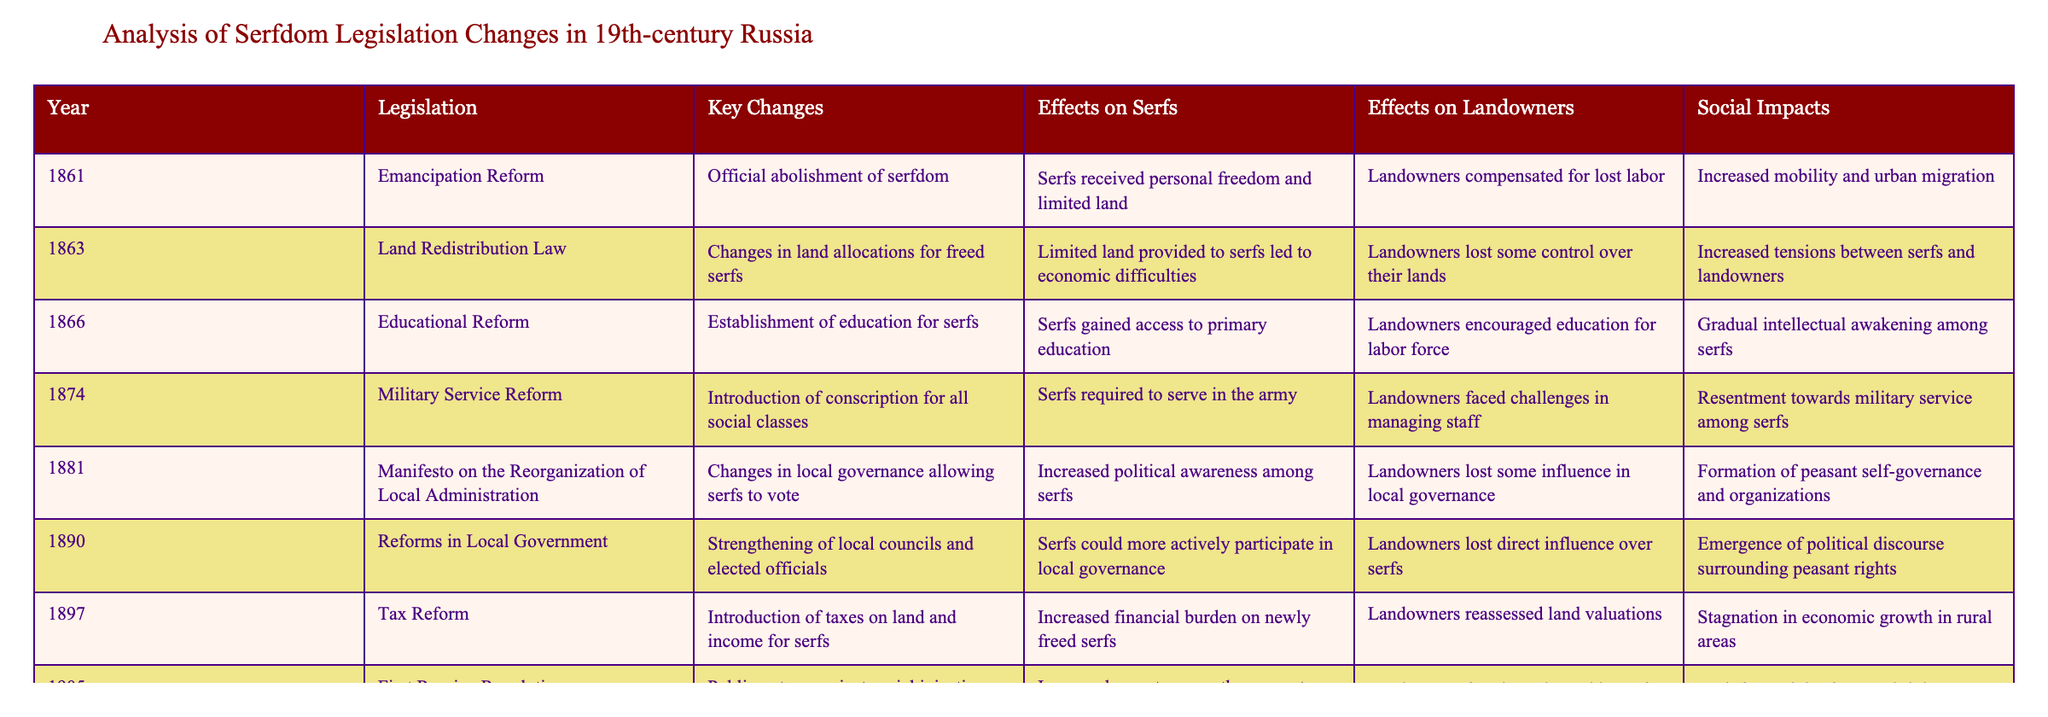What year did the Emancipation Reform take place? The table lists the years corresponding to the legislation changes, and the Emancipation Reform is noted in the first row as occurring in 1861.
Answer: 1861 What effects did the Land Redistribution Law have on serfs? According to the table, the effects of the Land Redistribution Law on serfs included limited land provided, which led to economic difficulties.
Answer: Economic difficulties How many significant reforms related to serfdom were introduced between 1861 and 1905? By counting the rows in the table between the years 1861 and 1905, we find a total of six significant reforms.
Answer: Six reforms What was a key social impact of the 1905 First Russian Revolution? The table states that the 1905 First Russian Revolution resulted in increased unrest among the peasantry.
Answer: Increased unrest among the peasantry Did serfs gain access to education before the 1905 First Russian Revolution? The Educational Reform of 1866 established primary education for serfs, which shows that they did gain access to education before that date.
Answer: Yes Which reform resulted in serfs being required to serve in the army? The Military Service Reform in 1874 made it obligatory for serfs to serve in the army, as indicated in the table.
Answer: Military Service Reform What effect did the 1881 manifesto have on landowners? The Manifesto on the Reorganization of Local Administration in 1881 led to a loss of influence for landowners in local governance as stated in the effects on landowners column.
Answer: Loss of influence What social impact resulted from the Tax Reform of 1897? The Tax Reform had the social impact of stagnation in economic growth in rural areas, according to the table.
Answer: Stagnation in economic growth Compare the effects on serfs from the Educational Reform of 1866 and the Military Service Reform of 1874. The Educational Reform allowed serfs access to education, contributing to an intellectual awakening. In contrast, the Military Service Reform required serfs to serve in the army, which led to resentment among them.
Answer: Access to education vs. resentment Between the Land Redistribution Law and the Reforms in Local Government, which reform had a more positive effect on serfs? The Reforms in Local Government provided serfs with more active participation in local governance, which can be seen as more positive compared to the limited land leading to difficulties from the Land Redistribution Law.
Answer: Reforms in Local Government Identify if serfs gained personal freedom before or after 1866. The Emancipation Reform in 1861 officially abolished serfdom and thus provided personal freedom to the serfs before the year 1866.
Answer: Before 1866 